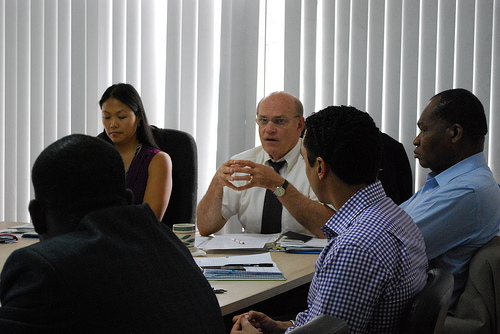<image>
Is there a tea cub to the right of the paper? No. The tea cub is not to the right of the paper. The horizontal positioning shows a different relationship. 